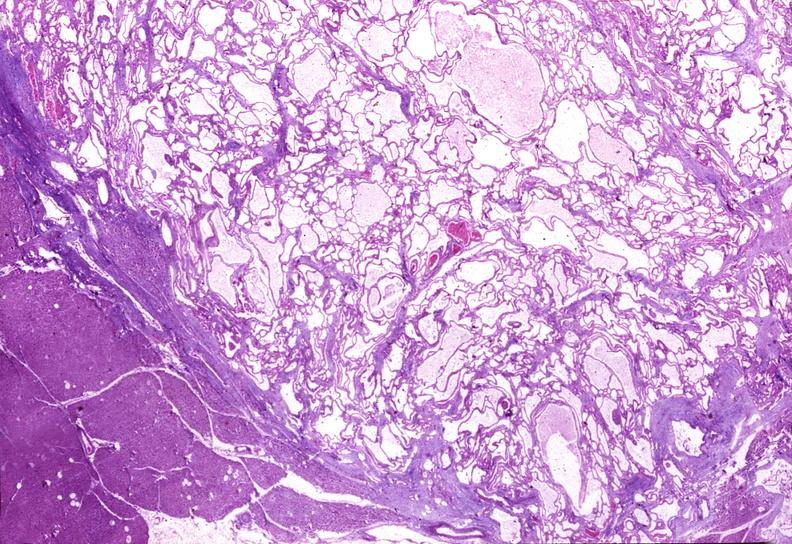what does this image show?
Answer the question using a single word or phrase. Cystadenoma 